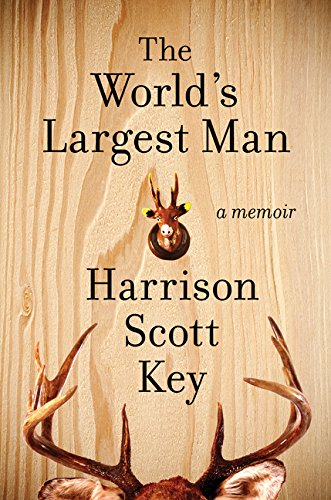What themes does the author explore in 'The World's Largest Man'? In 'The World's Largest Man', Harrison Scott Key explores themes of fatherhood, cultural identity, and the complexities of familial relationships within the humorous frame of his Southern background. 